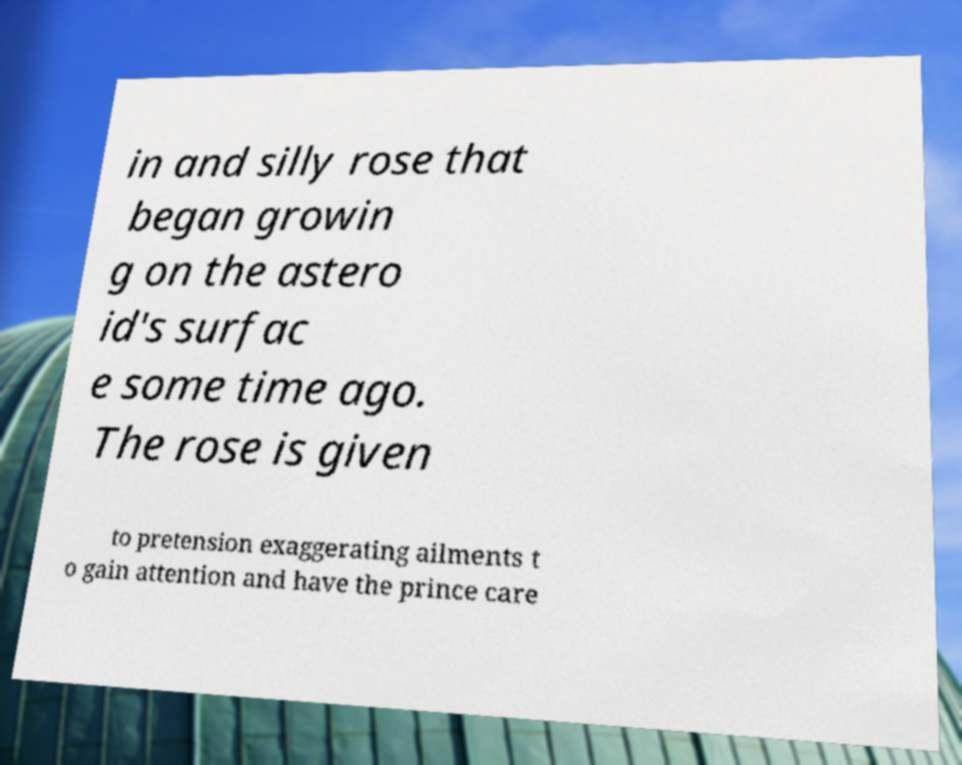Could you assist in decoding the text presented in this image and type it out clearly? in and silly rose that began growin g on the astero id's surfac e some time ago. The rose is given to pretension exaggerating ailments t o gain attention and have the prince care 